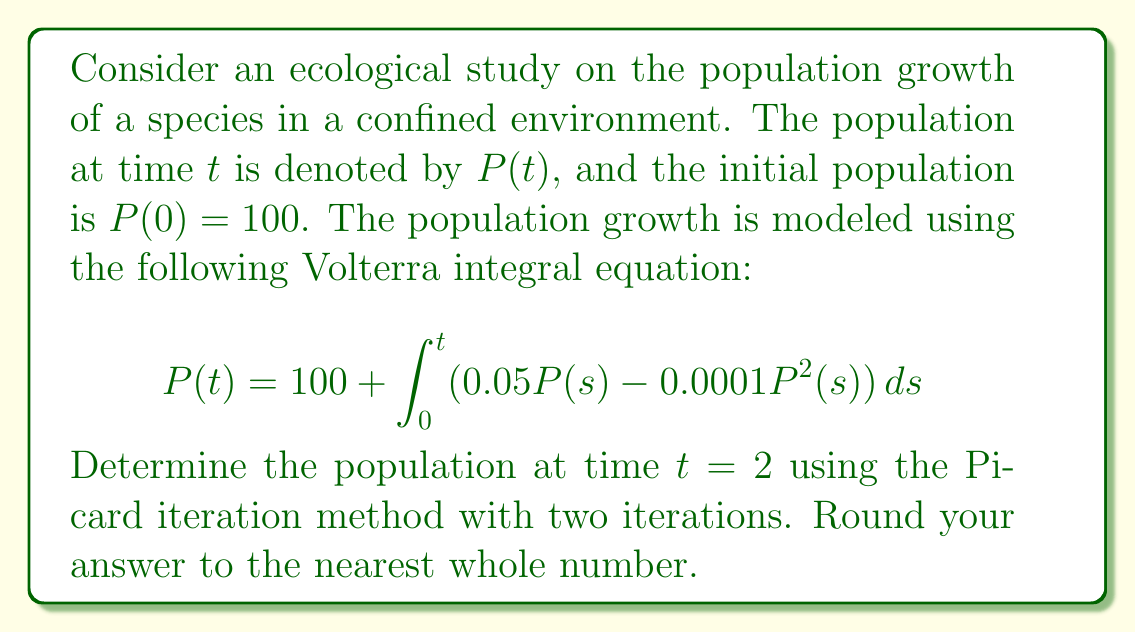Can you solve this math problem? To solve this problem using the Picard iteration method, we'll follow these steps:

1) Start with the initial approximation $P_0(t) = 100$ (the initial population).

2) Use the Volterra integral equation to generate subsequent approximations:

   $P_{n+1}(t) = 100 + \int_0^t (0.05P_n(s) - 0.0001P_n^2(s)) ds$

3) First iteration:
   $P_1(t) = 100 + \int_0^t (0.05 \cdot 100 - 0.0001 \cdot 100^2) ds$
   $= 100 + \int_0^t (5 - 1) ds$
   $= 100 + 4t$

4) Second iteration:
   $P_2(t) = 100 + \int_0^t (0.05(100 + 4s) - 0.0001(100 + 4s)^2) ds$
   $= 100 + \int_0^t (5 + 0.2s - 1 - 0.08s - 0.0016s^2) ds$
   $= 100 + \int_0^t (4 + 0.12s - 0.0016s^2) ds$
   $= 100 + 4t + 0.06t^2 - \frac{0.0016}{3}t^3$

5) Evaluate $P_2(t)$ at $t = 2$:
   $P_2(2) = 100 + 4(2) + 0.06(2^2) - \frac{0.0016}{3}(2^3)$
   $= 100 + 8 + 0.24 - 0.0085333...$
   $\approx 108.2315$

6) Rounding to the nearest whole number: 108
Answer: 108 